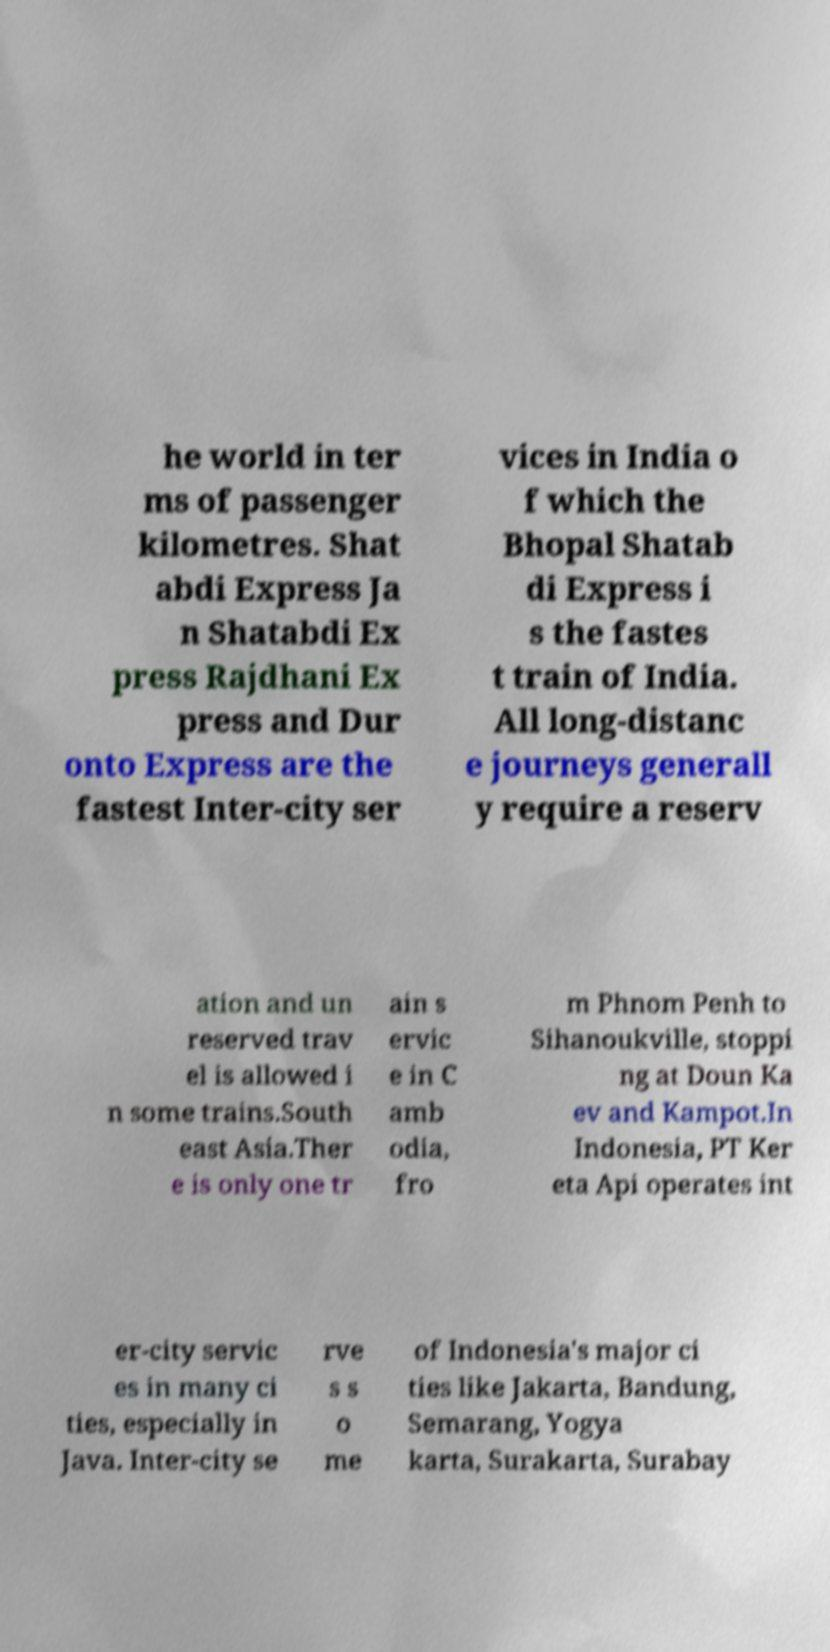There's text embedded in this image that I need extracted. Can you transcribe it verbatim? he world in ter ms of passenger kilometres. Shat abdi Express Ja n Shatabdi Ex press Rajdhani Ex press and Dur onto Express are the fastest Inter-city ser vices in India o f which the Bhopal Shatab di Express i s the fastes t train of India. All long-distanc e journeys generall y require a reserv ation and un reserved trav el is allowed i n some trains.South east Asia.Ther e is only one tr ain s ervic e in C amb odia, fro m Phnom Penh to Sihanoukville, stoppi ng at Doun Ka ev and Kampot.In Indonesia, PT Ker eta Api operates int er-city servic es in many ci ties, especially in Java. Inter-city se rve s s o me of Indonesia's major ci ties like Jakarta, Bandung, Semarang, Yogya karta, Surakarta, Surabay 